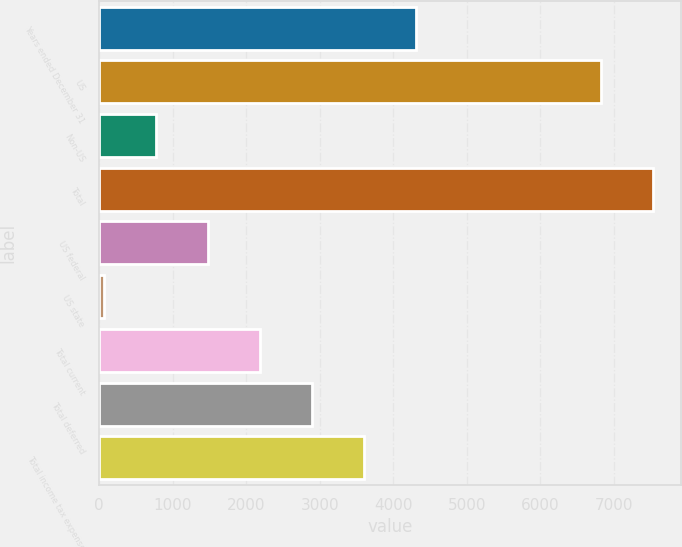Convert chart. <chart><loc_0><loc_0><loc_500><loc_500><bar_chart><fcel>Years ended December 31<fcel>US<fcel>Non-US<fcel>Total<fcel>US federal<fcel>US state<fcel>Total current<fcel>Total deferred<fcel>Total income tax expense<nl><fcel>4309.8<fcel>6829<fcel>775.8<fcel>7535.8<fcel>1482.6<fcel>69<fcel>2189.4<fcel>2896.2<fcel>3603<nl></chart> 